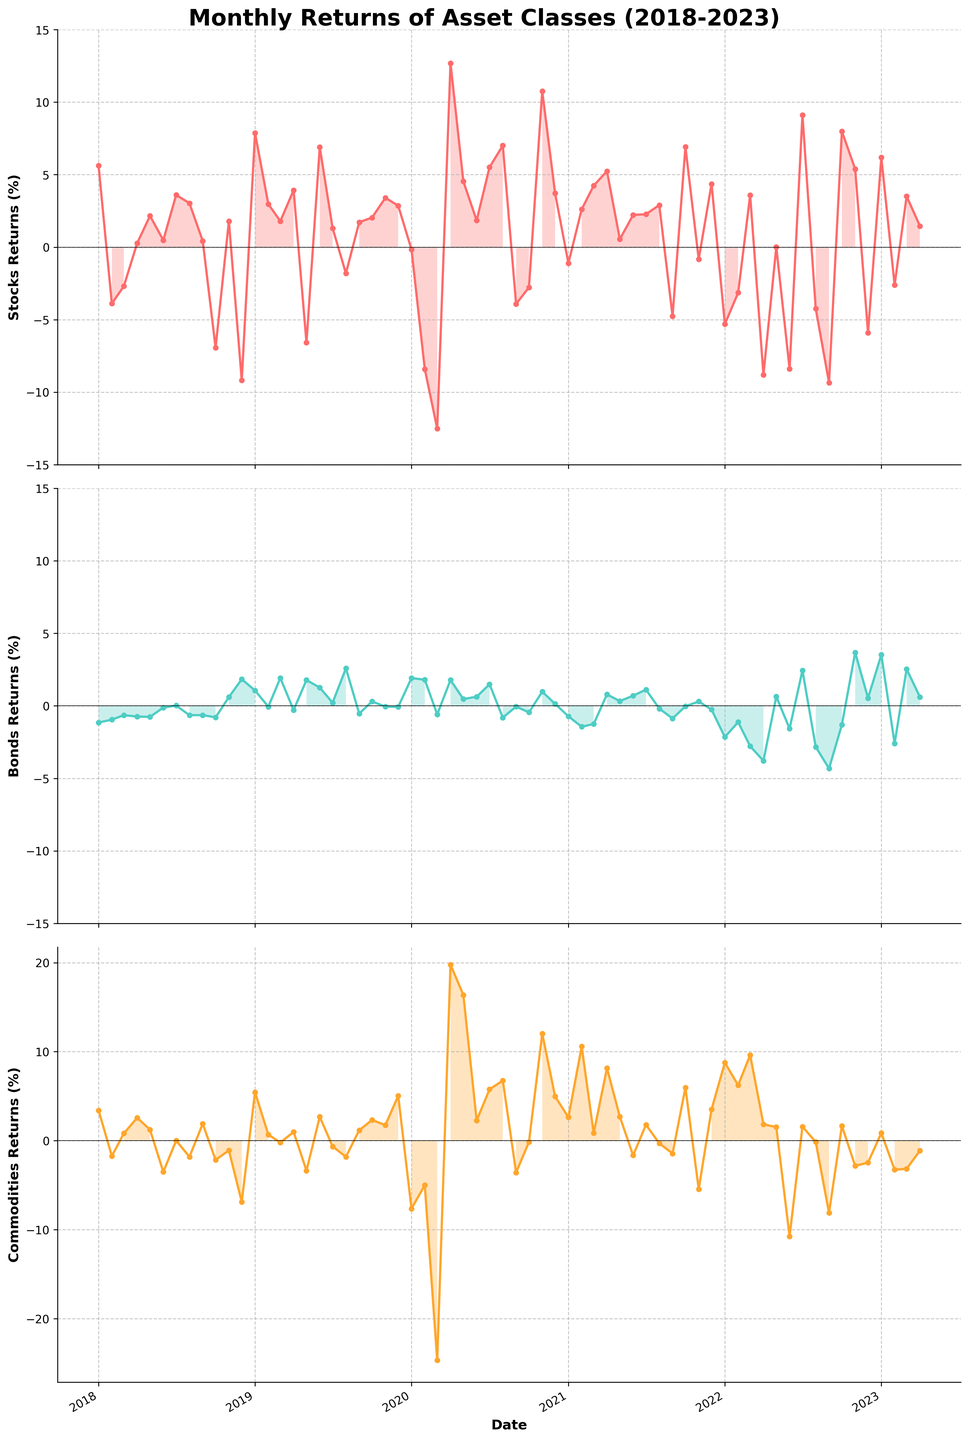Which asset class showed the highest peak return in the last five years? By observing the maximal peaks in the plots, we can see that commodities had the highest peak return in April 2020.
Answer: Commodities What was the average monthly return of bonds over the last five years? Add all the monthly returns of bonds and divide by the number of months. The sum of the returns is (sum of all Bonds values) = 10.98. The number of months is 64. So, the average is 10.98 / 64 = 0.1715%.
Answer: 0.1715% Which asset class had the most negative return in a single month, and when did it occur? By comparing the lowest points in each of the plots, we see that commodities had the most negative return in March 2020.
Answer: Commodities, March 2020 How did the returns of stocks and commodities compare in November 2020? Locate November 2020 on both the stocks and commodities plots. Stocks had a return of 10.75%, and commodities had a return of 12.04%. Compare these values.
Answer: Commodities had a higher return Which asset class showed the most volatile returns over the period? Volatility is visualized through the amplitude of fluctuations in the plot. Commodities seem to have the widest range of fluctuations compared to stocks and bonds.
Answer: Commodities In which months did stocks show a significant recovery after a drop in early 2020? Identify the drop period in early 2020 from the stocks plot, notice the recovery period starting in April 2020 with a significant uptick.
Answer: April 2020 By how much did the returns of stocks change from October 2018 to November 2018? In October 2018, returns for stocks were -6.94%, and in November 2018, they were 1.79%. The change is calculated as 1.79% - (-6.94%) = 8.73%.
Answer: 8.73% What can be inferred about the correlation between bonds and commodities returns over the last five years? By visually comparing the bond and commodities plots, we see that the returns often move in opposite directions, suggesting a negative correlation.
Answer: Negative correlation Which asset class had a positive return in the majority of months and what does this signify? By counting the months with positive returns in each plot, we observe that bonds had positive returns in most months. This signifies more stability and consistent performance.
Answer: Bonds, stability How did commodities perform in comparison to stocks in the year 2021? Analyze the entire year of 2021 in both plots. Stocks generally performed well but with some dips, while commodities had significantly positive spikes.
Answer: Commodities performed better 